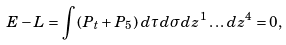<formula> <loc_0><loc_0><loc_500><loc_500>E - L = \int \left ( P _ { t } + P _ { 5 } \right ) \, d \tau d \sigma d z ^ { 1 } \dots d z ^ { 4 } = 0 ,</formula> 